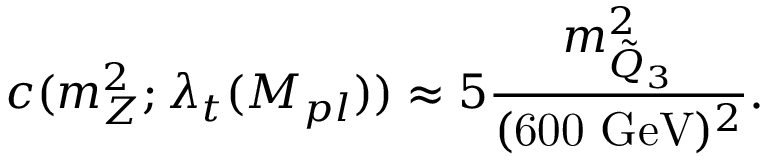<formula> <loc_0><loc_0><loc_500><loc_500>c ( m _ { Z } ^ { 2 } ; \lambda _ { t } ( M _ { p l } ) ) \approx 5 \frac { m _ { \tilde { Q } _ { 3 } } ^ { 2 } } { ( 6 0 0 G e V ) ^ { 2 } } .</formula> 